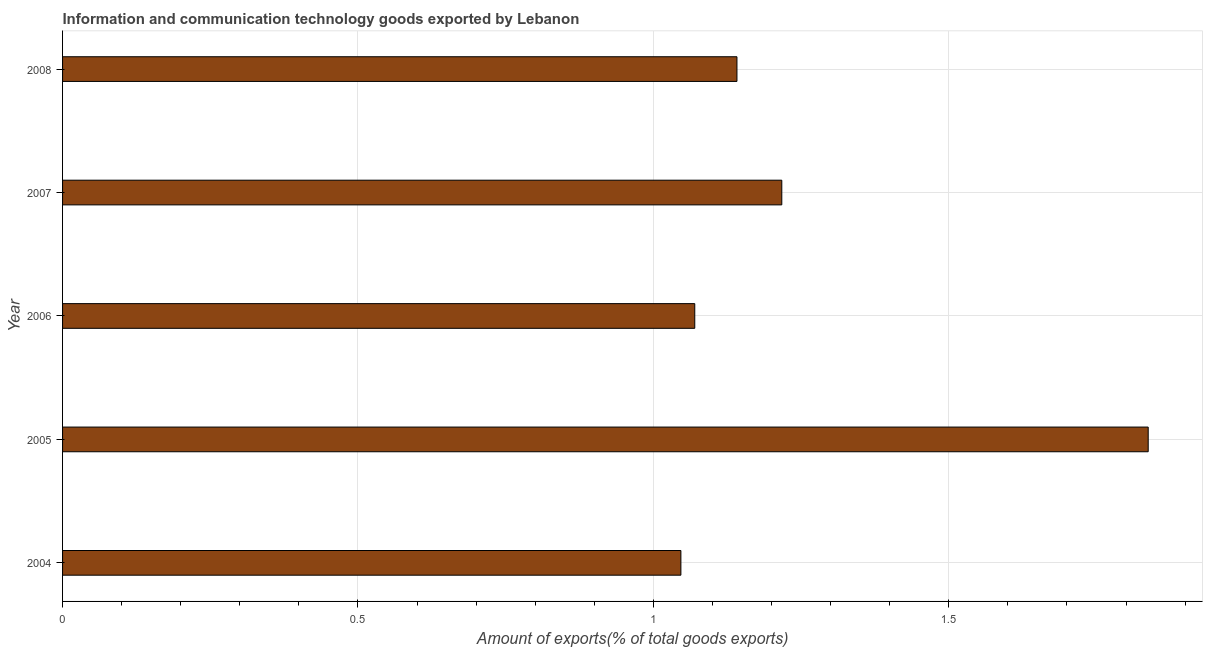Does the graph contain grids?
Offer a terse response. Yes. What is the title of the graph?
Offer a terse response. Information and communication technology goods exported by Lebanon. What is the label or title of the X-axis?
Keep it short and to the point. Amount of exports(% of total goods exports). What is the label or title of the Y-axis?
Offer a terse response. Year. What is the amount of ict goods exports in 2006?
Keep it short and to the point. 1.07. Across all years, what is the maximum amount of ict goods exports?
Provide a succinct answer. 1.84. Across all years, what is the minimum amount of ict goods exports?
Offer a terse response. 1.05. What is the sum of the amount of ict goods exports?
Ensure brevity in your answer.  6.31. What is the difference between the amount of ict goods exports in 2005 and 2008?
Your answer should be compact. 0.7. What is the average amount of ict goods exports per year?
Offer a terse response. 1.26. What is the median amount of ict goods exports?
Your answer should be very brief. 1.14. In how many years, is the amount of ict goods exports greater than 0.5 %?
Ensure brevity in your answer.  5. Do a majority of the years between 2008 and 2007 (inclusive) have amount of ict goods exports greater than 1.6 %?
Ensure brevity in your answer.  No. What is the ratio of the amount of ict goods exports in 2005 to that in 2007?
Provide a succinct answer. 1.51. Is the amount of ict goods exports in 2004 less than that in 2006?
Provide a short and direct response. Yes. What is the difference between the highest and the second highest amount of ict goods exports?
Give a very brief answer. 0.62. What is the difference between the highest and the lowest amount of ict goods exports?
Ensure brevity in your answer.  0.79. Are all the bars in the graph horizontal?
Provide a short and direct response. Yes. What is the difference between two consecutive major ticks on the X-axis?
Your answer should be compact. 0.5. Are the values on the major ticks of X-axis written in scientific E-notation?
Give a very brief answer. No. What is the Amount of exports(% of total goods exports) of 2004?
Ensure brevity in your answer.  1.05. What is the Amount of exports(% of total goods exports) in 2005?
Provide a succinct answer. 1.84. What is the Amount of exports(% of total goods exports) in 2006?
Provide a short and direct response. 1.07. What is the Amount of exports(% of total goods exports) in 2007?
Your answer should be compact. 1.22. What is the Amount of exports(% of total goods exports) in 2008?
Ensure brevity in your answer.  1.14. What is the difference between the Amount of exports(% of total goods exports) in 2004 and 2005?
Provide a short and direct response. -0.79. What is the difference between the Amount of exports(% of total goods exports) in 2004 and 2006?
Offer a very short reply. -0.02. What is the difference between the Amount of exports(% of total goods exports) in 2004 and 2007?
Make the answer very short. -0.17. What is the difference between the Amount of exports(% of total goods exports) in 2004 and 2008?
Ensure brevity in your answer.  -0.09. What is the difference between the Amount of exports(% of total goods exports) in 2005 and 2006?
Keep it short and to the point. 0.77. What is the difference between the Amount of exports(% of total goods exports) in 2005 and 2007?
Provide a short and direct response. 0.62. What is the difference between the Amount of exports(% of total goods exports) in 2005 and 2008?
Offer a very short reply. 0.7. What is the difference between the Amount of exports(% of total goods exports) in 2006 and 2007?
Offer a terse response. -0.15. What is the difference between the Amount of exports(% of total goods exports) in 2006 and 2008?
Offer a very short reply. -0.07. What is the difference between the Amount of exports(% of total goods exports) in 2007 and 2008?
Give a very brief answer. 0.08. What is the ratio of the Amount of exports(% of total goods exports) in 2004 to that in 2005?
Provide a short and direct response. 0.57. What is the ratio of the Amount of exports(% of total goods exports) in 2004 to that in 2007?
Give a very brief answer. 0.86. What is the ratio of the Amount of exports(% of total goods exports) in 2004 to that in 2008?
Provide a succinct answer. 0.92. What is the ratio of the Amount of exports(% of total goods exports) in 2005 to that in 2006?
Your answer should be compact. 1.72. What is the ratio of the Amount of exports(% of total goods exports) in 2005 to that in 2007?
Ensure brevity in your answer.  1.51. What is the ratio of the Amount of exports(% of total goods exports) in 2005 to that in 2008?
Provide a succinct answer. 1.61. What is the ratio of the Amount of exports(% of total goods exports) in 2006 to that in 2007?
Keep it short and to the point. 0.88. What is the ratio of the Amount of exports(% of total goods exports) in 2006 to that in 2008?
Keep it short and to the point. 0.94. What is the ratio of the Amount of exports(% of total goods exports) in 2007 to that in 2008?
Offer a very short reply. 1.07. 